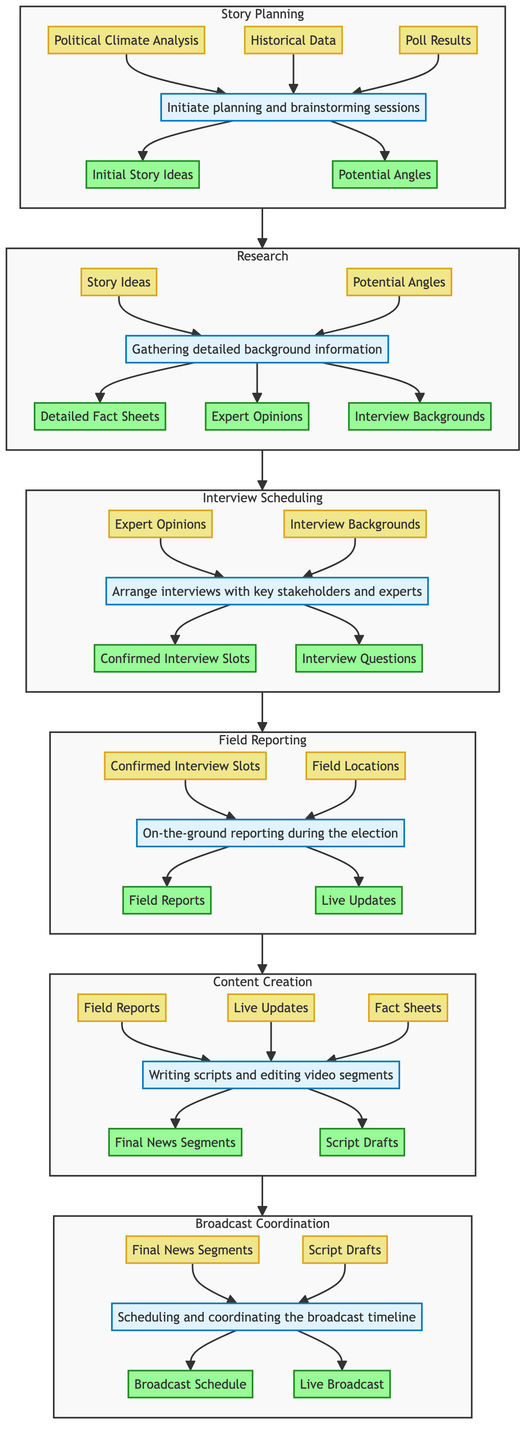What are the outputs of the Story Planning phase? The outputs of the Story Planning phase are derived from the process defined in the diagram. The elements connected from the process node "Initiate planning and brainstorming sessions" lead to two outputs: "Initial Story Ideas" and "Potential Angles".
Answer: Initial Story Ideas, Potential Angles Who is responsible for the Field Reporting phase? The responsibilities are clearly specified in the diagram. The phase "On-the-ground reporting during the election" has two roles assigned: "Political Correspondent" and "Camera Crew".
Answer: Political Correspondent, Camera Crew What inputs are needed for the Content Creation phase? To determine the inputs for Content Creation, we look at what is connected to the process node "Writing scripts and editing video segments". There are three inputs listed: "Field Reports", "Live Updates", and "Fact Sheets".
Answer: Field Reports, Live Updates, Fact Sheets How many main phases are in the election coverage plan? The diagram presents six distinct phases involved in the election coverage plan, each represented as a separate subgraph in the flow. These phases flow from Story Planning through to Broadcast Coordination.
Answer: 6 What is the relationship between Research and Interview Scheduling? To understand their relationship, we see that the output from the Research phase feeds directly into Interview Scheduling. Specifically, the outputs "Detailed Fact Sheets", "Expert Opinions", and "Interview Backgrounds" from Research become the inputs for Interview Scheduling.
Answer: Direct connection What are the final outputs of the Broadcast Coordination phase? The last phase, Broadcast Coordination, produces two distinct final outputs as outlined in the diagram: "Broadcast Schedule" and "Live Broadcast". These are the end results after processing the inputs from the previous phase.
Answer: Broadcast Schedule, Live Broadcast How many inputs does the Interview Scheduling phase receive? In the diagram, the Interview Scheduling phase is shown to have two inputs: "Expert Opinions" and "Interview Backgrounds". This indicates that for this phase to proceed, these two pieces of information are required.
Answer: 2 Which roles are involved in the Content Creation phase? The diagram specifies the roles involved in the Content Creation phase, which are "News Producers", "Writers", and "Editors". These stakeholders collaborate to produce the contents for broadcast.
Answer: News Producers, Writers, Editors What is the process defined in the Field Reporting phase? The process for the Field Reporting phase is outlined as "On-the-ground reporting during the election". This succinctly describes the main activity that occurs during this phase as indicated in the diagram.
Answer: On-the-ground reporting during the election 